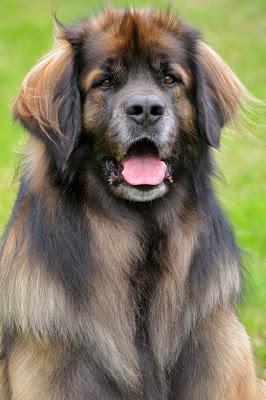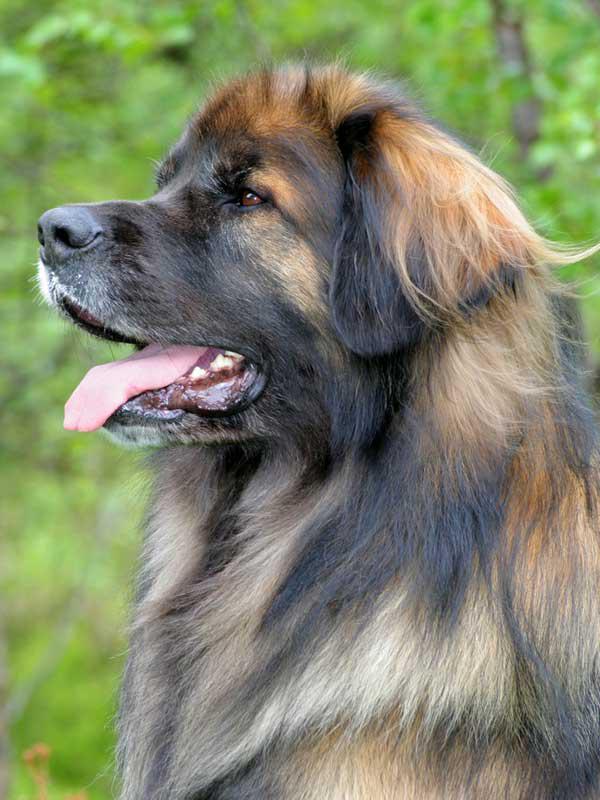The first image is the image on the left, the second image is the image on the right. For the images displayed, is the sentence "The dog in the left image is looking towards the right with its tongue hanging out." factually correct? Answer yes or no. No. 